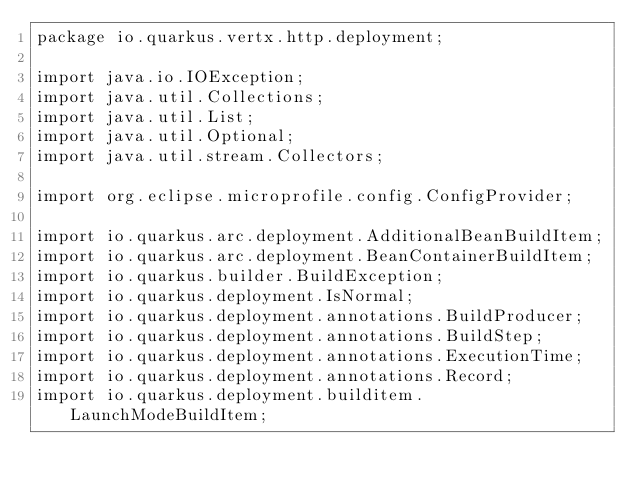Convert code to text. <code><loc_0><loc_0><loc_500><loc_500><_Java_>package io.quarkus.vertx.http.deployment;

import java.io.IOException;
import java.util.Collections;
import java.util.List;
import java.util.Optional;
import java.util.stream.Collectors;

import org.eclipse.microprofile.config.ConfigProvider;

import io.quarkus.arc.deployment.AdditionalBeanBuildItem;
import io.quarkus.arc.deployment.BeanContainerBuildItem;
import io.quarkus.builder.BuildException;
import io.quarkus.deployment.IsNormal;
import io.quarkus.deployment.annotations.BuildProducer;
import io.quarkus.deployment.annotations.BuildStep;
import io.quarkus.deployment.annotations.ExecutionTime;
import io.quarkus.deployment.annotations.Record;
import io.quarkus.deployment.builditem.LaunchModeBuildItem;</code> 